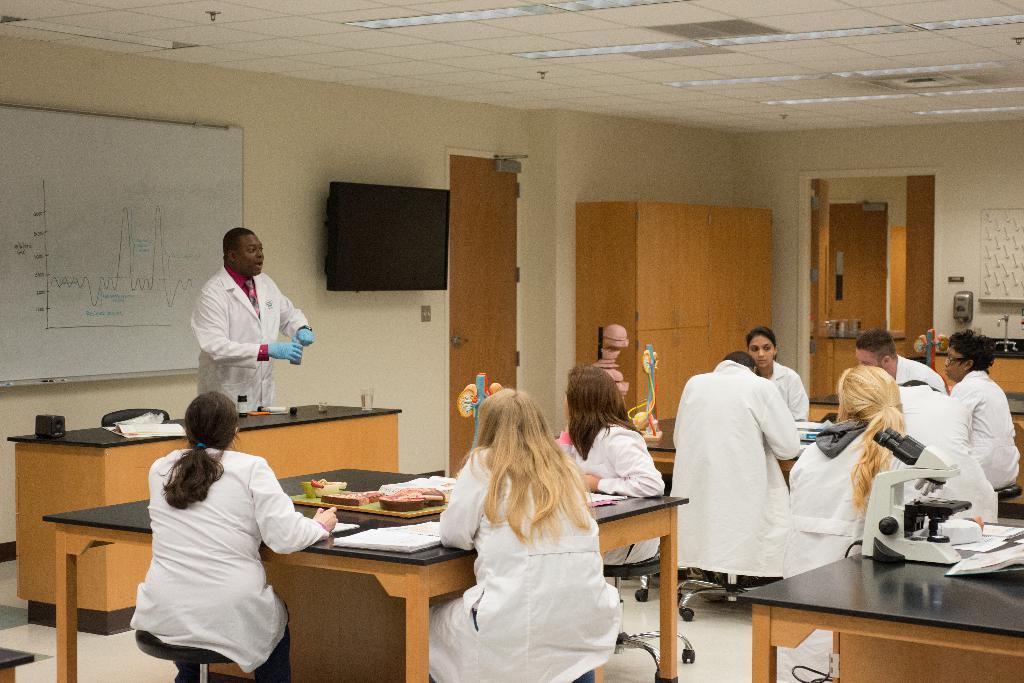In one or two sentences, can you explain what this image depicts? Group people sitting on the chairs and this person standing and holding object. We can see books,board,glass and objects on the tables. On the background we can see wall,board,television,door,furniture. On the top we can see lights. This is floor. 